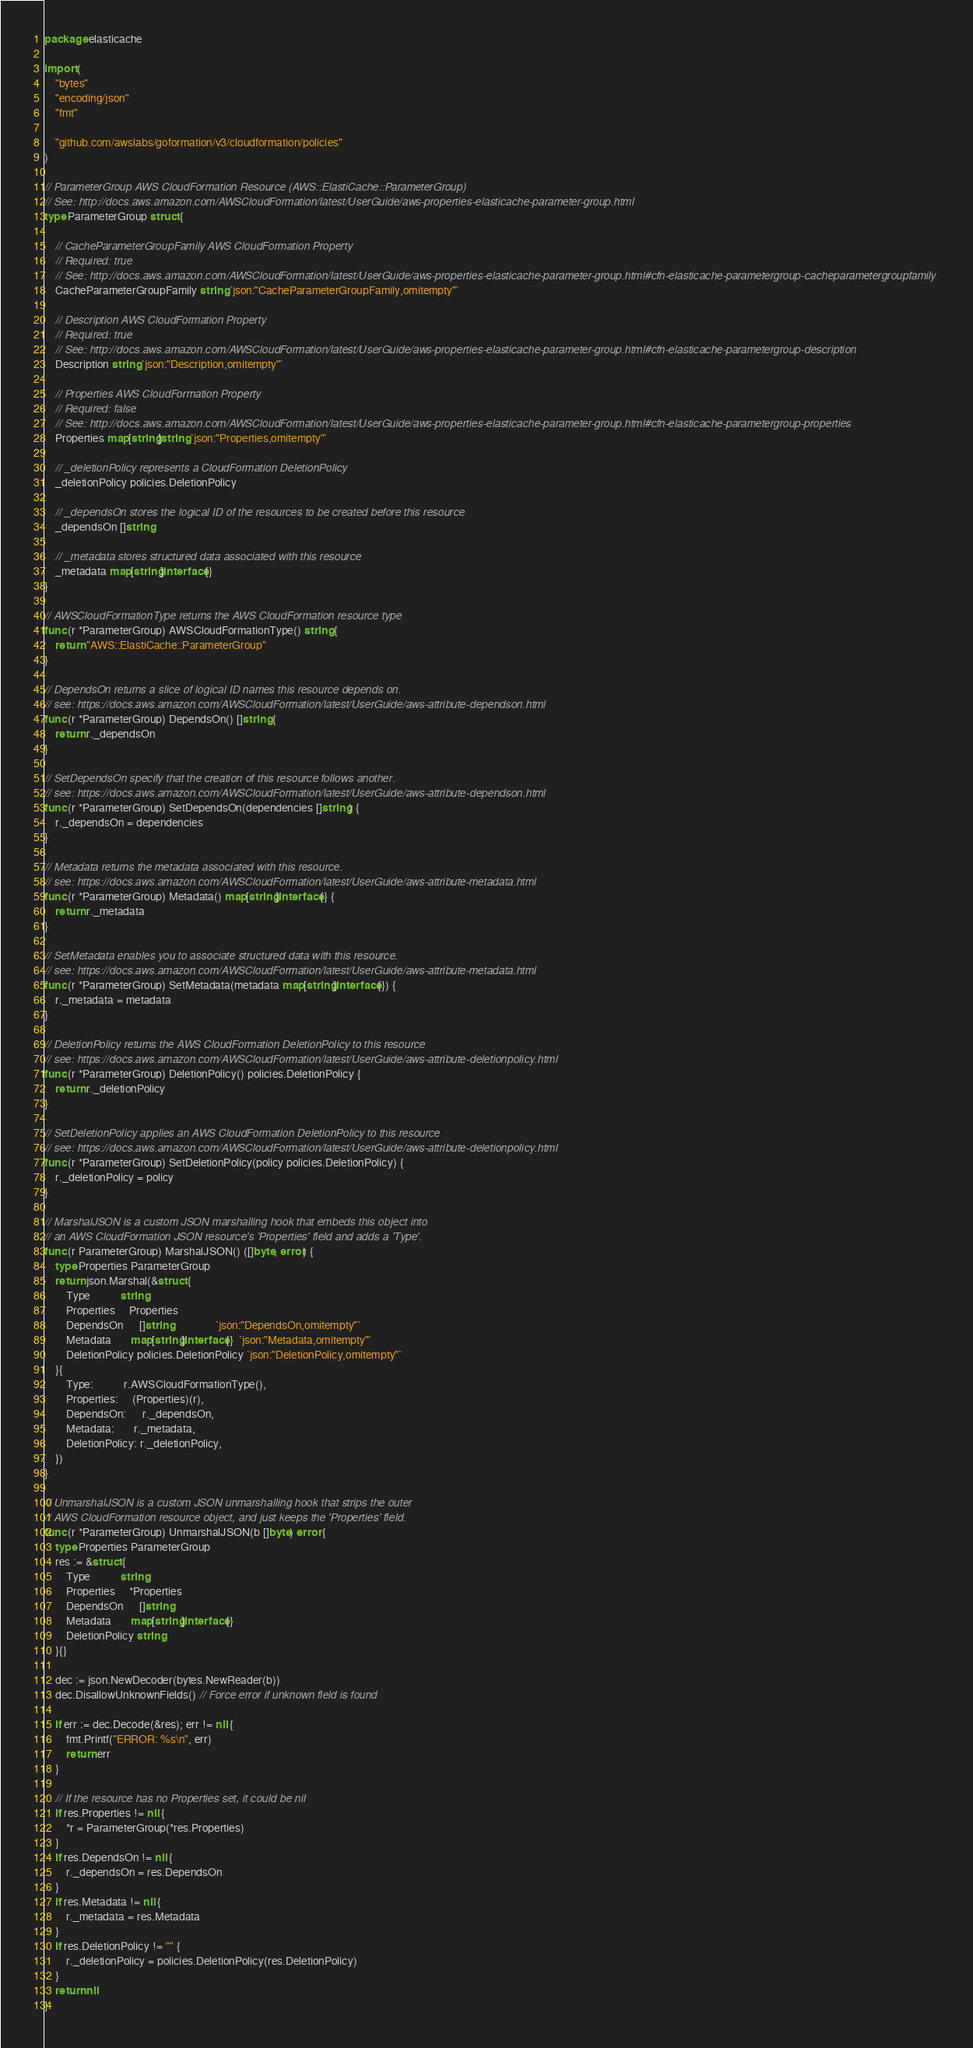<code> <loc_0><loc_0><loc_500><loc_500><_Go_>package elasticache

import (
	"bytes"
	"encoding/json"
	"fmt"

	"github.com/awslabs/goformation/v3/cloudformation/policies"
)

// ParameterGroup AWS CloudFormation Resource (AWS::ElastiCache::ParameterGroup)
// See: http://docs.aws.amazon.com/AWSCloudFormation/latest/UserGuide/aws-properties-elasticache-parameter-group.html
type ParameterGroup struct {

	// CacheParameterGroupFamily AWS CloudFormation Property
	// Required: true
	// See: http://docs.aws.amazon.com/AWSCloudFormation/latest/UserGuide/aws-properties-elasticache-parameter-group.html#cfn-elasticache-parametergroup-cacheparametergroupfamily
	CacheParameterGroupFamily string `json:"CacheParameterGroupFamily,omitempty"`

	// Description AWS CloudFormation Property
	// Required: true
	// See: http://docs.aws.amazon.com/AWSCloudFormation/latest/UserGuide/aws-properties-elasticache-parameter-group.html#cfn-elasticache-parametergroup-description
	Description string `json:"Description,omitempty"`

	// Properties AWS CloudFormation Property
	// Required: false
	// See: http://docs.aws.amazon.com/AWSCloudFormation/latest/UserGuide/aws-properties-elasticache-parameter-group.html#cfn-elasticache-parametergroup-properties
	Properties map[string]string `json:"Properties,omitempty"`

	// _deletionPolicy represents a CloudFormation DeletionPolicy
	_deletionPolicy policies.DeletionPolicy

	// _dependsOn stores the logical ID of the resources to be created before this resource
	_dependsOn []string

	// _metadata stores structured data associated with this resource
	_metadata map[string]interface{}
}

// AWSCloudFormationType returns the AWS CloudFormation resource type
func (r *ParameterGroup) AWSCloudFormationType() string {
	return "AWS::ElastiCache::ParameterGroup"
}

// DependsOn returns a slice of logical ID names this resource depends on.
// see: https://docs.aws.amazon.com/AWSCloudFormation/latest/UserGuide/aws-attribute-dependson.html
func (r *ParameterGroup) DependsOn() []string {
	return r._dependsOn
}

// SetDependsOn specify that the creation of this resource follows another.
// see: https://docs.aws.amazon.com/AWSCloudFormation/latest/UserGuide/aws-attribute-dependson.html
func (r *ParameterGroup) SetDependsOn(dependencies []string) {
	r._dependsOn = dependencies
}

// Metadata returns the metadata associated with this resource.
// see: https://docs.aws.amazon.com/AWSCloudFormation/latest/UserGuide/aws-attribute-metadata.html
func (r *ParameterGroup) Metadata() map[string]interface{} {
	return r._metadata
}

// SetMetadata enables you to associate structured data with this resource.
// see: https://docs.aws.amazon.com/AWSCloudFormation/latest/UserGuide/aws-attribute-metadata.html
func (r *ParameterGroup) SetMetadata(metadata map[string]interface{}) {
	r._metadata = metadata
}

// DeletionPolicy returns the AWS CloudFormation DeletionPolicy to this resource
// see: https://docs.aws.amazon.com/AWSCloudFormation/latest/UserGuide/aws-attribute-deletionpolicy.html
func (r *ParameterGroup) DeletionPolicy() policies.DeletionPolicy {
	return r._deletionPolicy
}

// SetDeletionPolicy applies an AWS CloudFormation DeletionPolicy to this resource
// see: https://docs.aws.amazon.com/AWSCloudFormation/latest/UserGuide/aws-attribute-deletionpolicy.html
func (r *ParameterGroup) SetDeletionPolicy(policy policies.DeletionPolicy) {
	r._deletionPolicy = policy
}

// MarshalJSON is a custom JSON marshalling hook that embeds this object into
// an AWS CloudFormation JSON resource's 'Properties' field and adds a 'Type'.
func (r ParameterGroup) MarshalJSON() ([]byte, error) {
	type Properties ParameterGroup
	return json.Marshal(&struct {
		Type           string
		Properties     Properties
		DependsOn      []string                `json:"DependsOn,omitempty"`
		Metadata       map[string]interface{}  `json:"Metadata,omitempty"`
		DeletionPolicy policies.DeletionPolicy `json:"DeletionPolicy,omitempty"`
	}{
		Type:           r.AWSCloudFormationType(),
		Properties:     (Properties)(r),
		DependsOn:      r._dependsOn,
		Metadata:       r._metadata,
		DeletionPolicy: r._deletionPolicy,
	})
}

// UnmarshalJSON is a custom JSON unmarshalling hook that strips the outer
// AWS CloudFormation resource object, and just keeps the 'Properties' field.
func (r *ParameterGroup) UnmarshalJSON(b []byte) error {
	type Properties ParameterGroup
	res := &struct {
		Type           string
		Properties     *Properties
		DependsOn      []string
		Metadata       map[string]interface{}
		DeletionPolicy string
	}{}

	dec := json.NewDecoder(bytes.NewReader(b))
	dec.DisallowUnknownFields() // Force error if unknown field is found

	if err := dec.Decode(&res); err != nil {
		fmt.Printf("ERROR: %s\n", err)
		return err
	}

	// If the resource has no Properties set, it could be nil
	if res.Properties != nil {
		*r = ParameterGroup(*res.Properties)
	}
	if res.DependsOn != nil {
		r._dependsOn = res.DependsOn
	}
	if res.Metadata != nil {
		r._metadata = res.Metadata
	}
	if res.DeletionPolicy != "" {
		r._deletionPolicy = policies.DeletionPolicy(res.DeletionPolicy)
	}
	return nil
}
</code> 